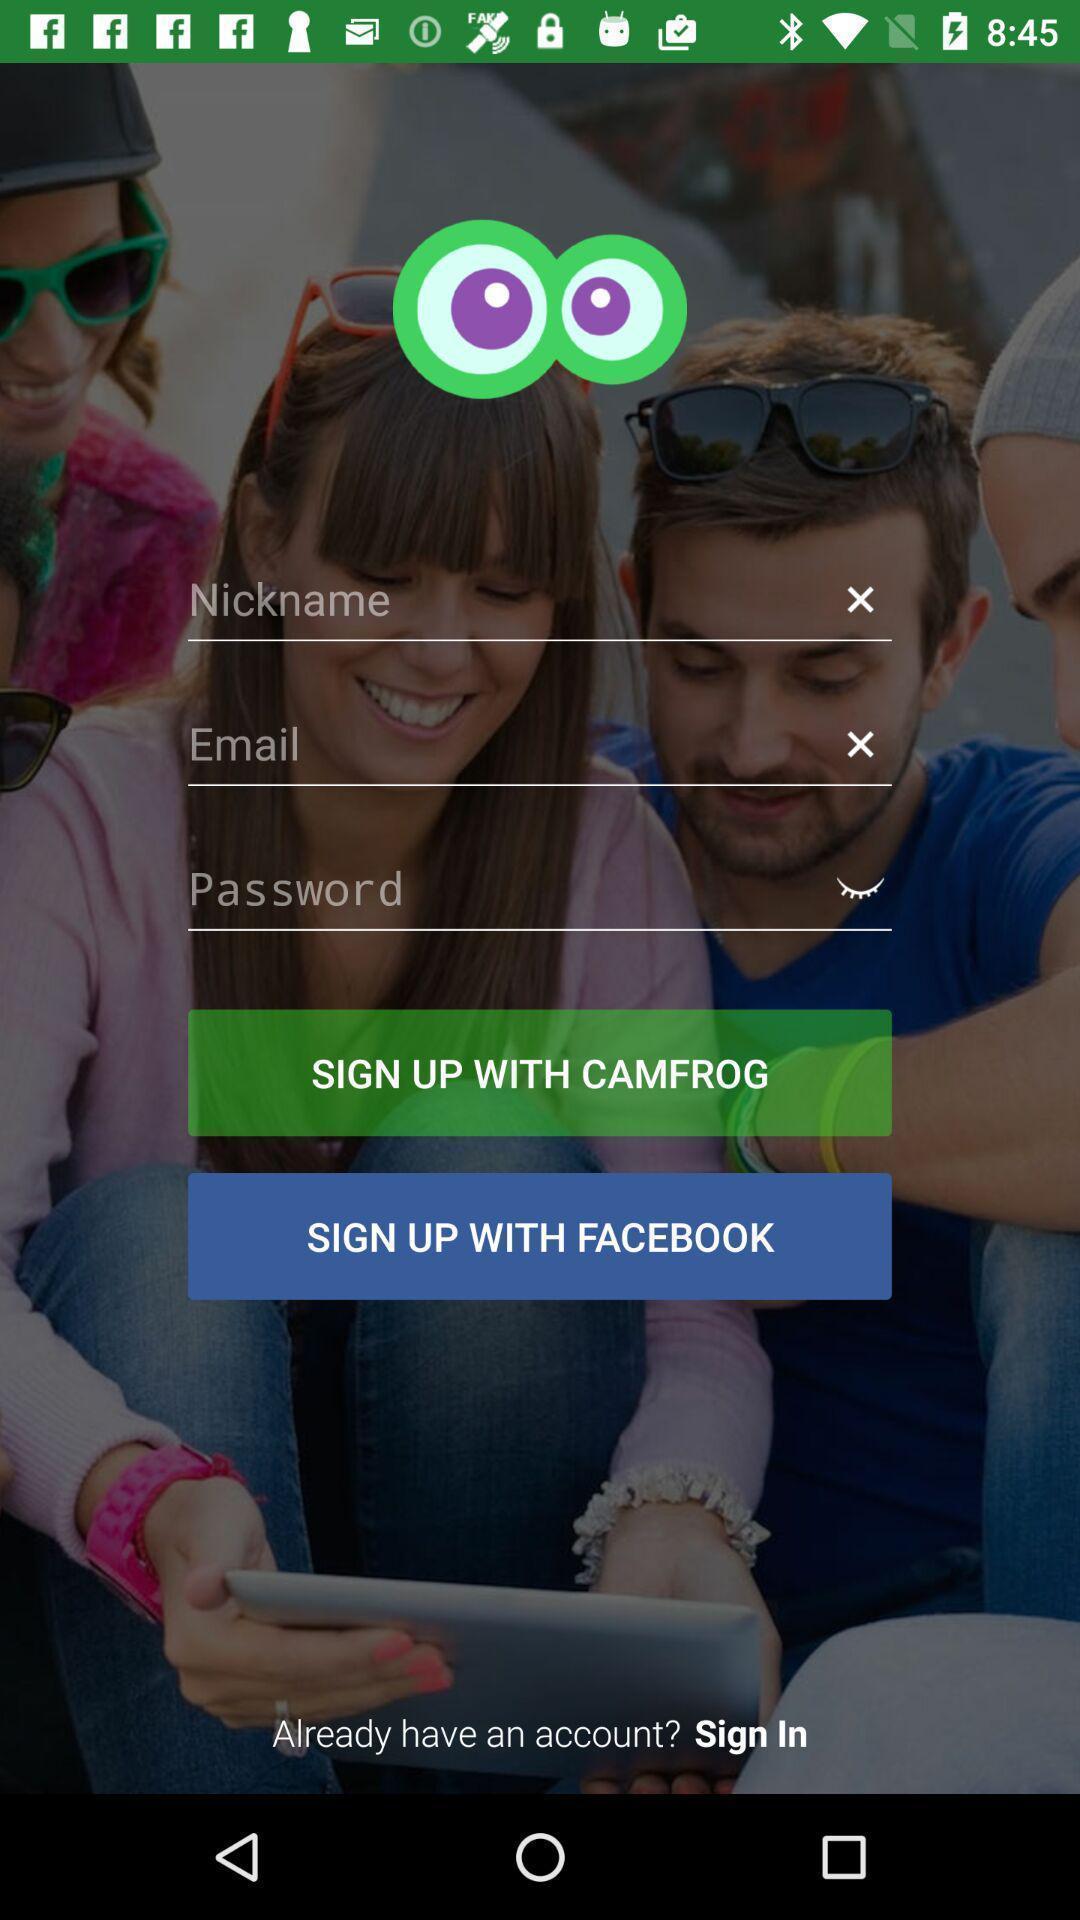Describe the key features of this screenshot. Sign up page. 